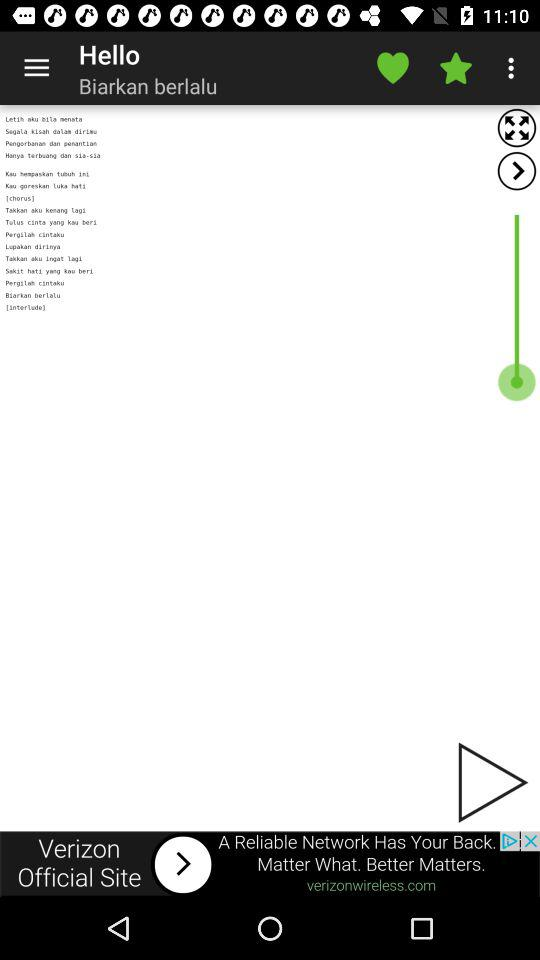What is the singer name? The singer name is Biarkan Berlalu. 